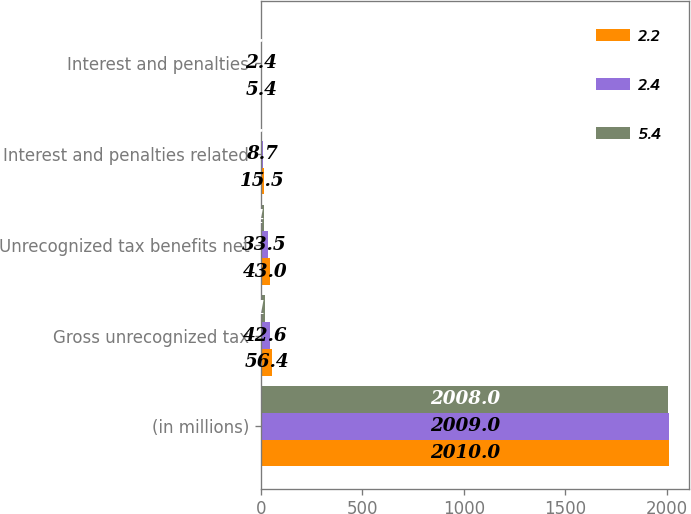<chart> <loc_0><loc_0><loc_500><loc_500><stacked_bar_chart><ecel><fcel>(in millions)<fcel>Gross unrecognized tax<fcel>Unrecognized tax benefits net<fcel>Interest and penalties related<fcel>Interest and penalties<nl><fcel>2.2<fcel>2010<fcel>56.4<fcel>43<fcel>15.5<fcel>5.4<nl><fcel>2.4<fcel>2009<fcel>42.6<fcel>33.5<fcel>8.7<fcel>2.4<nl><fcel>5.4<fcel>2008<fcel>21.5<fcel>14.7<fcel>6.7<fcel>2.2<nl></chart> 